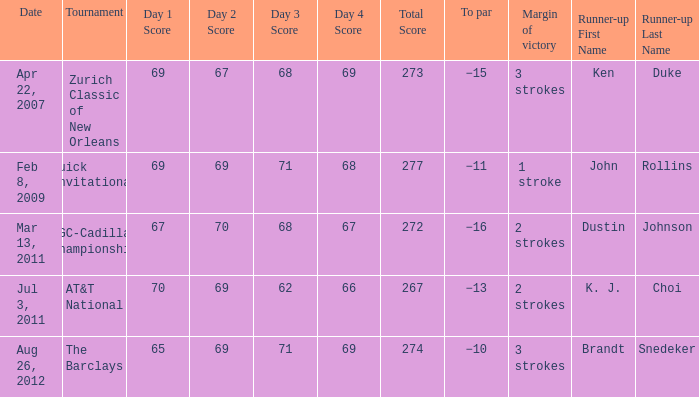What was the to par of the tournament that had Ken Duke as a runner-up? −15. 